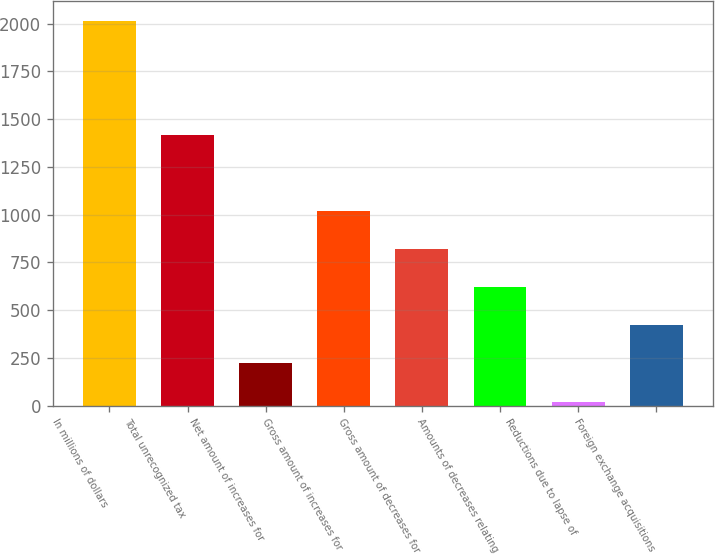<chart> <loc_0><loc_0><loc_500><loc_500><bar_chart><fcel>In millions of dollars<fcel>Total unrecognized tax<fcel>Net amount of increases for<fcel>Gross amount of increases for<fcel>Gross amount of decreases for<fcel>Amounts of decreases relating<fcel>Reductions due to lapse of<fcel>Foreign exchange acquisitions<nl><fcel>2015<fcel>1417.1<fcel>221.3<fcel>1018.5<fcel>819.2<fcel>619.9<fcel>22<fcel>420.6<nl></chart> 